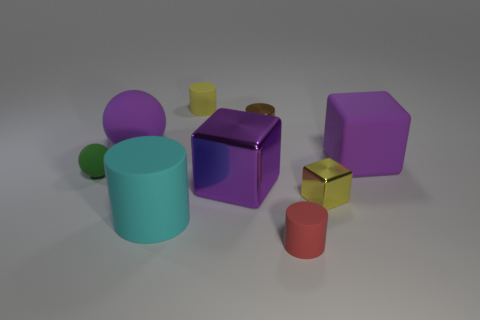Subtract all spheres. How many objects are left? 7 Subtract all tiny cyan rubber objects. Subtract all red things. How many objects are left? 8 Add 2 large matte spheres. How many large matte spheres are left? 3 Add 9 gray rubber cylinders. How many gray rubber cylinders exist? 9 Subtract 1 yellow cylinders. How many objects are left? 8 